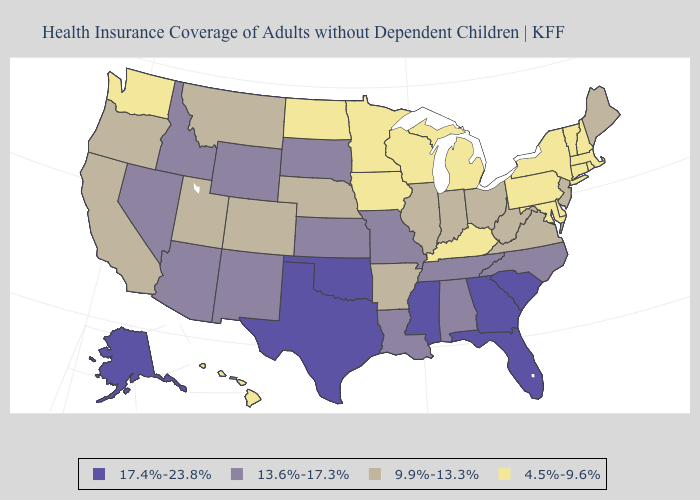What is the value of Connecticut?
Be succinct. 4.5%-9.6%. What is the lowest value in the USA?
Answer briefly. 4.5%-9.6%. Does South Carolina have a higher value than Georgia?
Give a very brief answer. No. Name the states that have a value in the range 13.6%-17.3%?
Keep it brief. Alabama, Arizona, Idaho, Kansas, Louisiana, Missouri, Nevada, New Mexico, North Carolina, South Dakota, Tennessee, Wyoming. Which states have the lowest value in the Northeast?
Be succinct. Connecticut, Massachusetts, New Hampshire, New York, Pennsylvania, Rhode Island, Vermont. Which states hav the highest value in the West?
Give a very brief answer. Alaska. Name the states that have a value in the range 9.9%-13.3%?
Answer briefly. Arkansas, California, Colorado, Illinois, Indiana, Maine, Montana, Nebraska, New Jersey, Ohio, Oregon, Utah, Virginia, West Virginia. What is the highest value in states that border New Jersey?
Quick response, please. 4.5%-9.6%. What is the highest value in the USA?
Keep it brief. 17.4%-23.8%. What is the value of North Dakota?
Short answer required. 4.5%-9.6%. Name the states that have a value in the range 13.6%-17.3%?
Concise answer only. Alabama, Arizona, Idaho, Kansas, Louisiana, Missouri, Nevada, New Mexico, North Carolina, South Dakota, Tennessee, Wyoming. Name the states that have a value in the range 4.5%-9.6%?
Short answer required. Connecticut, Delaware, Hawaii, Iowa, Kentucky, Maryland, Massachusetts, Michigan, Minnesota, New Hampshire, New York, North Dakota, Pennsylvania, Rhode Island, Vermont, Washington, Wisconsin. Name the states that have a value in the range 13.6%-17.3%?
Short answer required. Alabama, Arizona, Idaho, Kansas, Louisiana, Missouri, Nevada, New Mexico, North Carolina, South Dakota, Tennessee, Wyoming. What is the highest value in the South ?
Quick response, please. 17.4%-23.8%. What is the value of Nebraska?
Give a very brief answer. 9.9%-13.3%. 